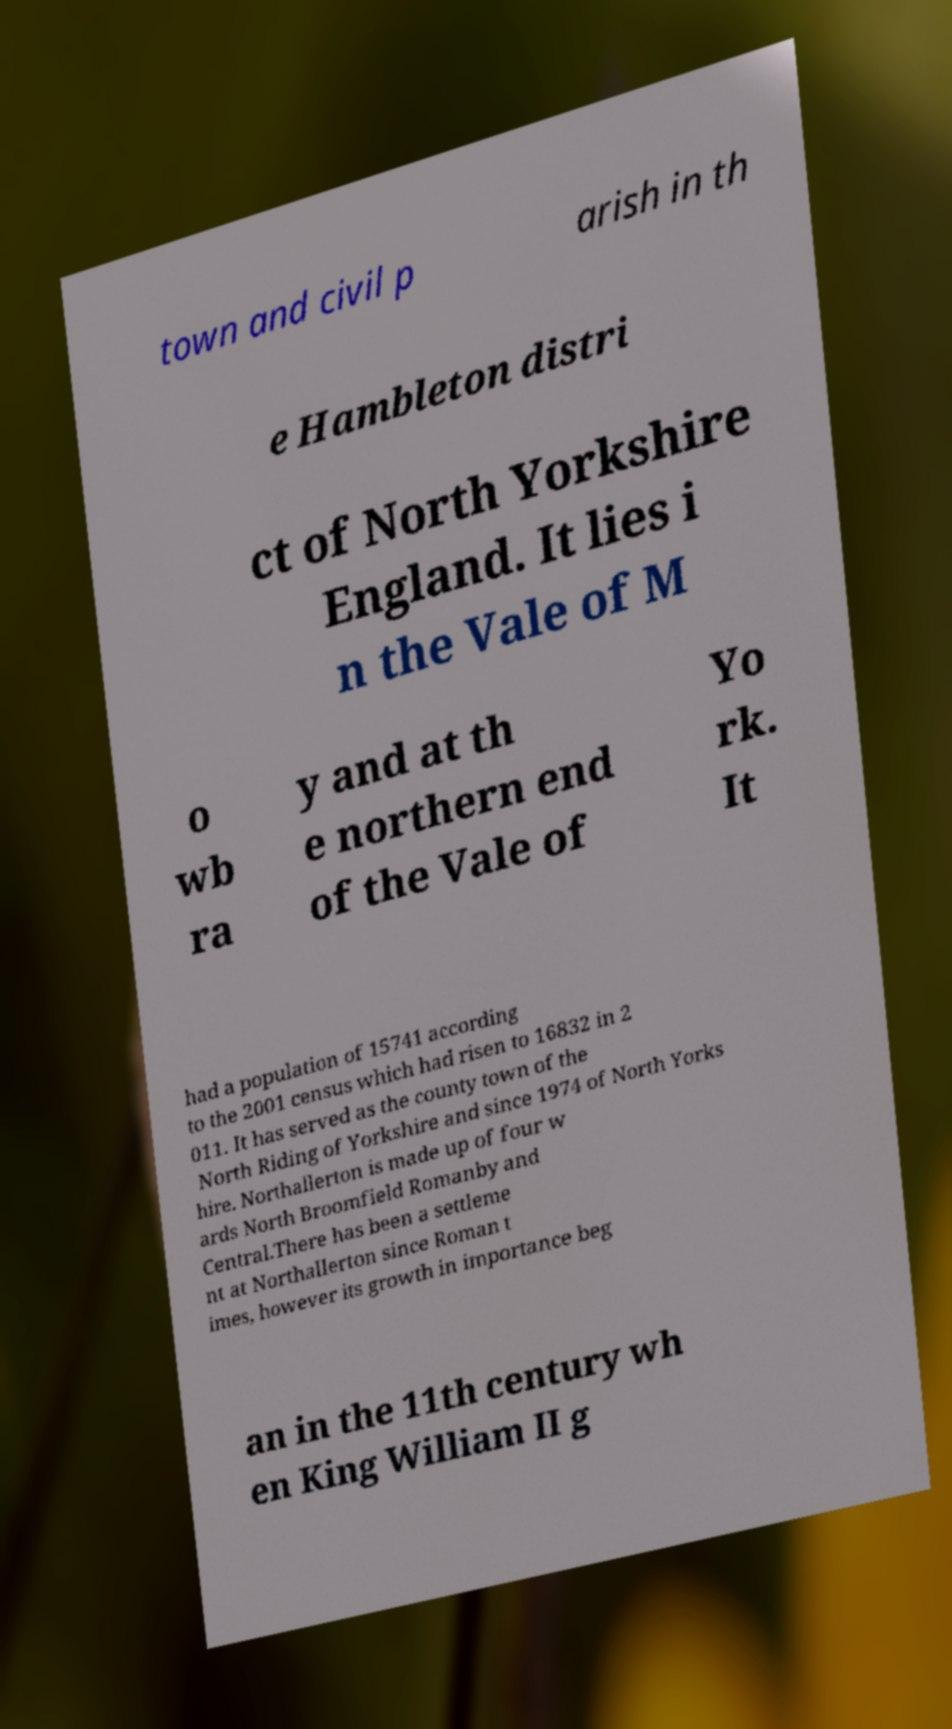Can you accurately transcribe the text from the provided image for me? town and civil p arish in th e Hambleton distri ct of North Yorkshire England. It lies i n the Vale of M o wb ra y and at th e northern end of the Vale of Yo rk. It had a population of 15741 according to the 2001 census which had risen to 16832 in 2 011. It has served as the county town of the North Riding of Yorkshire and since 1974 of North Yorks hire. Northallerton is made up of four w ards North Broomfield Romanby and Central.There has been a settleme nt at Northallerton since Roman t imes, however its growth in importance beg an in the 11th century wh en King William II g 